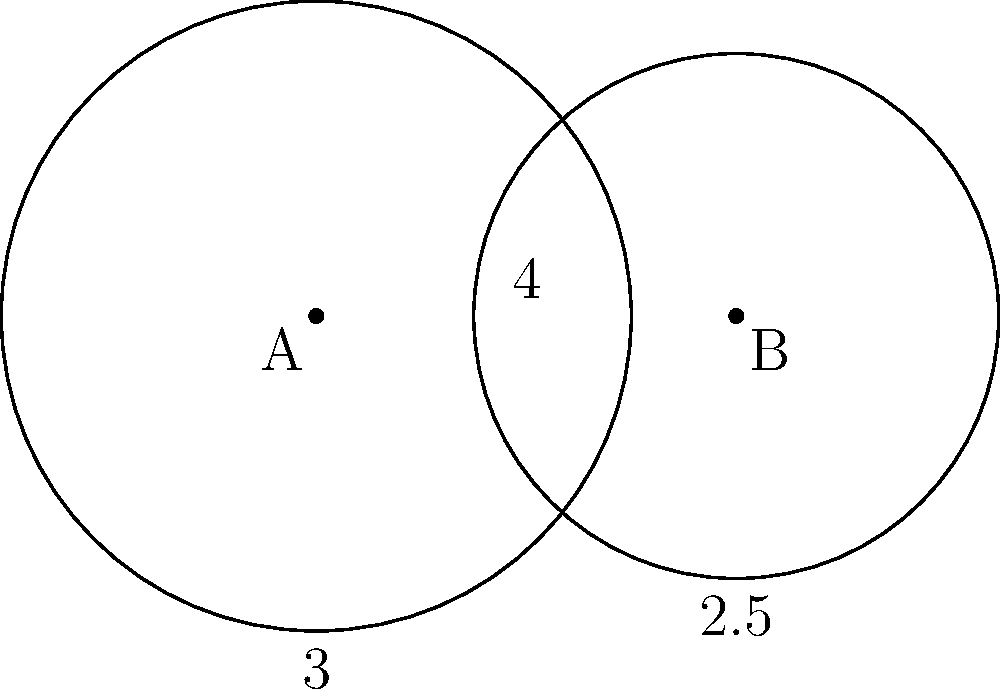As a business analyst organizing social evenings for international TV shows, you're analyzing the overlap in viewership between two popular series. The Venn diagram above represents the audience of these shows, with each circle depicting the total viewership of one show. Circle A has a radius of 3 units, circle B has a radius of 2.5 units, and their centers are 4 units apart. Calculate the area of the overlapping region, which represents the shared audience between the two shows. Round your answer to two decimal places. To find the area of overlap between two circles, we need to follow these steps:

1) First, we need to calculate the distance between the centers of the circles:
   $d = 4$ (given in the question)

2) Next, we need to find the angle $\theta$ (in radians) for each circle sector:
   For circle A: $\cos(\frac{\theta_A}{2}) = \frac{d^2 + r_A^2 - r_B^2}{2dr_A}$
   $\cos(\frac{\theta_A}{2}) = \frac{4^2 + 3^2 - 2.5^2}{2(4)(3)} = 0.7291667$
   $\theta_A = 2 \arccos(0.7291667) = 1.5904 \text{ radians}$

   For circle B: $\cos(\frac{\theta_B}{2}) = \frac{d^2 + r_B^2 - r_A^2}{2dr_B}$
   $\cos(\frac{\theta_B}{2}) = \frac{4^2 + 2.5^2 - 3^2}{2(4)(2.5)} = 0.675$
   $\theta_B = 2 \arccos(0.675) = 1.7249 \text{ radians}$

3) Now we can calculate the area of each circular sector:
   Area of sector A = $\frac{1}{2} r_A^2 \theta_A = \frac{1}{2} (3^2) (1.5904) = 7.1568$
   Area of sector B = $\frac{1}{2} r_B^2 \theta_B = \frac{1}{2} (2.5^2) (1.7249) = 5.3903$

4) Next, we calculate the area of each triangle:
   Area of triangle A = $\frac{1}{2} r_A^2 \sin(\theta_A) = \frac{1}{2} (3^2) \sin(1.5904) = 3.3758$
   Area of triangle B = $\frac{1}{2} r_B^2 \sin(\theta_B) = \frac{1}{2} (2.5^2) \sin(1.7249) = 2.6951$

5) The overlapping area is the sum of the sectors minus the sum of the triangles:
   Overlap area = $(7.1568 + 5.3903) - (3.3758 + 2.6951) = 6.4762$

6) Rounding to two decimal places: 6.48
Answer: 6.48 square units 